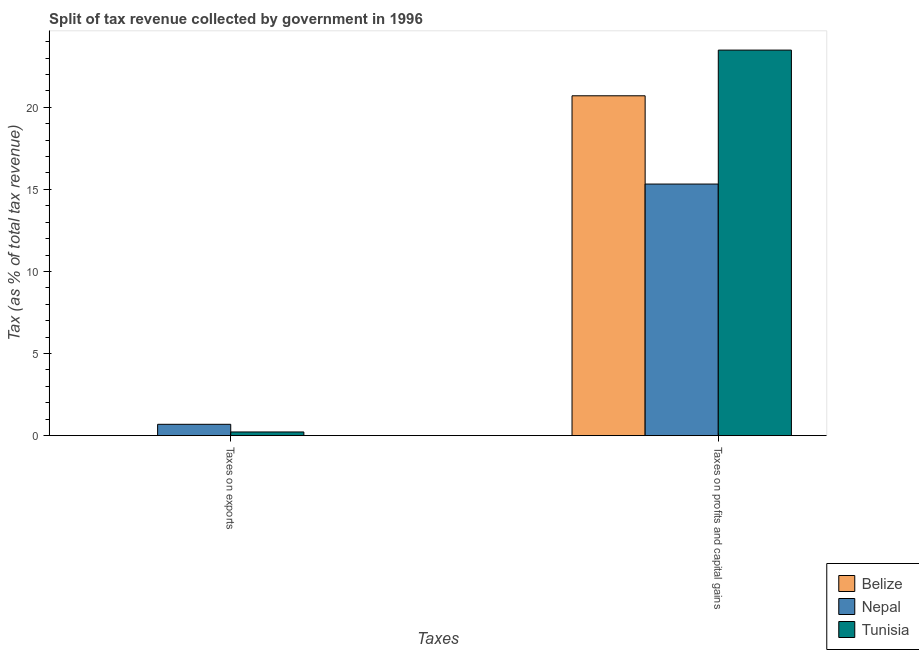How many groups of bars are there?
Keep it short and to the point. 2. Are the number of bars per tick equal to the number of legend labels?
Ensure brevity in your answer.  Yes. How many bars are there on the 2nd tick from the left?
Keep it short and to the point. 3. What is the label of the 1st group of bars from the left?
Your answer should be very brief. Taxes on exports. What is the percentage of revenue obtained from taxes on exports in Tunisia?
Offer a terse response. 0.22. Across all countries, what is the maximum percentage of revenue obtained from taxes on exports?
Keep it short and to the point. 0.69. Across all countries, what is the minimum percentage of revenue obtained from taxes on exports?
Your response must be concise. 0. In which country was the percentage of revenue obtained from taxes on profits and capital gains maximum?
Your answer should be very brief. Tunisia. In which country was the percentage of revenue obtained from taxes on profits and capital gains minimum?
Your answer should be compact. Nepal. What is the total percentage of revenue obtained from taxes on profits and capital gains in the graph?
Keep it short and to the point. 59.51. What is the difference between the percentage of revenue obtained from taxes on exports in Nepal and that in Belize?
Your answer should be very brief. 0.69. What is the difference between the percentage of revenue obtained from taxes on profits and capital gains in Nepal and the percentage of revenue obtained from taxes on exports in Tunisia?
Ensure brevity in your answer.  15.1. What is the average percentage of revenue obtained from taxes on exports per country?
Offer a terse response. 0.31. What is the difference between the percentage of revenue obtained from taxes on exports and percentage of revenue obtained from taxes on profits and capital gains in Tunisia?
Keep it short and to the point. -23.26. In how many countries, is the percentage of revenue obtained from taxes on profits and capital gains greater than 4 %?
Provide a succinct answer. 3. What is the ratio of the percentage of revenue obtained from taxes on exports in Belize to that in Nepal?
Your answer should be compact. 0.01. Is the percentage of revenue obtained from taxes on exports in Nepal less than that in Tunisia?
Your answer should be compact. No. In how many countries, is the percentage of revenue obtained from taxes on profits and capital gains greater than the average percentage of revenue obtained from taxes on profits and capital gains taken over all countries?
Your answer should be compact. 2. What does the 1st bar from the left in Taxes on exports represents?
Provide a short and direct response. Belize. What does the 2nd bar from the right in Taxes on profits and capital gains represents?
Give a very brief answer. Nepal. Are all the bars in the graph horizontal?
Provide a succinct answer. No. How many countries are there in the graph?
Give a very brief answer. 3. Where does the legend appear in the graph?
Offer a terse response. Bottom right. What is the title of the graph?
Provide a succinct answer. Split of tax revenue collected by government in 1996. Does "Japan" appear as one of the legend labels in the graph?
Provide a short and direct response. No. What is the label or title of the X-axis?
Offer a terse response. Taxes. What is the label or title of the Y-axis?
Give a very brief answer. Tax (as % of total tax revenue). What is the Tax (as % of total tax revenue) in Belize in Taxes on exports?
Give a very brief answer. 0. What is the Tax (as % of total tax revenue) of Nepal in Taxes on exports?
Provide a short and direct response. 0.69. What is the Tax (as % of total tax revenue) in Tunisia in Taxes on exports?
Provide a short and direct response. 0.22. What is the Tax (as % of total tax revenue) of Belize in Taxes on profits and capital gains?
Provide a succinct answer. 20.7. What is the Tax (as % of total tax revenue) of Nepal in Taxes on profits and capital gains?
Your response must be concise. 15.32. What is the Tax (as % of total tax revenue) in Tunisia in Taxes on profits and capital gains?
Give a very brief answer. 23.48. Across all Taxes, what is the maximum Tax (as % of total tax revenue) of Belize?
Offer a very short reply. 20.7. Across all Taxes, what is the maximum Tax (as % of total tax revenue) of Nepal?
Your answer should be compact. 15.32. Across all Taxes, what is the maximum Tax (as % of total tax revenue) of Tunisia?
Offer a very short reply. 23.48. Across all Taxes, what is the minimum Tax (as % of total tax revenue) of Belize?
Provide a short and direct response. 0. Across all Taxes, what is the minimum Tax (as % of total tax revenue) in Nepal?
Keep it short and to the point. 0.69. Across all Taxes, what is the minimum Tax (as % of total tax revenue) of Tunisia?
Your answer should be very brief. 0.22. What is the total Tax (as % of total tax revenue) in Belize in the graph?
Provide a succinct answer. 20.71. What is the total Tax (as % of total tax revenue) in Nepal in the graph?
Offer a terse response. 16.01. What is the total Tax (as % of total tax revenue) of Tunisia in the graph?
Offer a very short reply. 23.71. What is the difference between the Tax (as % of total tax revenue) in Belize in Taxes on exports and that in Taxes on profits and capital gains?
Make the answer very short. -20.7. What is the difference between the Tax (as % of total tax revenue) in Nepal in Taxes on exports and that in Taxes on profits and capital gains?
Your answer should be very brief. -14.63. What is the difference between the Tax (as % of total tax revenue) of Tunisia in Taxes on exports and that in Taxes on profits and capital gains?
Your response must be concise. -23.26. What is the difference between the Tax (as % of total tax revenue) in Belize in Taxes on exports and the Tax (as % of total tax revenue) in Nepal in Taxes on profits and capital gains?
Provide a short and direct response. -15.32. What is the difference between the Tax (as % of total tax revenue) of Belize in Taxes on exports and the Tax (as % of total tax revenue) of Tunisia in Taxes on profits and capital gains?
Your response must be concise. -23.48. What is the difference between the Tax (as % of total tax revenue) in Nepal in Taxes on exports and the Tax (as % of total tax revenue) in Tunisia in Taxes on profits and capital gains?
Your answer should be very brief. -22.79. What is the average Tax (as % of total tax revenue) in Belize per Taxes?
Keep it short and to the point. 10.35. What is the average Tax (as % of total tax revenue) in Nepal per Taxes?
Provide a succinct answer. 8.01. What is the average Tax (as % of total tax revenue) of Tunisia per Taxes?
Provide a short and direct response. 11.85. What is the difference between the Tax (as % of total tax revenue) of Belize and Tax (as % of total tax revenue) of Nepal in Taxes on exports?
Ensure brevity in your answer.  -0.69. What is the difference between the Tax (as % of total tax revenue) in Belize and Tax (as % of total tax revenue) in Tunisia in Taxes on exports?
Ensure brevity in your answer.  -0.22. What is the difference between the Tax (as % of total tax revenue) of Nepal and Tax (as % of total tax revenue) of Tunisia in Taxes on exports?
Keep it short and to the point. 0.47. What is the difference between the Tax (as % of total tax revenue) in Belize and Tax (as % of total tax revenue) in Nepal in Taxes on profits and capital gains?
Your answer should be very brief. 5.38. What is the difference between the Tax (as % of total tax revenue) of Belize and Tax (as % of total tax revenue) of Tunisia in Taxes on profits and capital gains?
Your answer should be compact. -2.78. What is the difference between the Tax (as % of total tax revenue) of Nepal and Tax (as % of total tax revenue) of Tunisia in Taxes on profits and capital gains?
Your answer should be compact. -8.16. What is the ratio of the Tax (as % of total tax revenue) of Belize in Taxes on exports to that in Taxes on profits and capital gains?
Provide a succinct answer. 0. What is the ratio of the Tax (as % of total tax revenue) of Nepal in Taxes on exports to that in Taxes on profits and capital gains?
Provide a succinct answer. 0.05. What is the ratio of the Tax (as % of total tax revenue) of Tunisia in Taxes on exports to that in Taxes on profits and capital gains?
Keep it short and to the point. 0.01. What is the difference between the highest and the second highest Tax (as % of total tax revenue) of Belize?
Offer a terse response. 20.7. What is the difference between the highest and the second highest Tax (as % of total tax revenue) in Nepal?
Offer a terse response. 14.63. What is the difference between the highest and the second highest Tax (as % of total tax revenue) in Tunisia?
Make the answer very short. 23.26. What is the difference between the highest and the lowest Tax (as % of total tax revenue) in Belize?
Your answer should be very brief. 20.7. What is the difference between the highest and the lowest Tax (as % of total tax revenue) of Nepal?
Make the answer very short. 14.63. What is the difference between the highest and the lowest Tax (as % of total tax revenue) in Tunisia?
Ensure brevity in your answer.  23.26. 